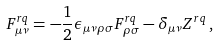<formula> <loc_0><loc_0><loc_500><loc_500>F _ { \mu \nu } ^ { r q } = - \frac { 1 } { 2 } \epsilon _ { \mu \nu \rho \sigma } F _ { \rho \sigma } ^ { r q } - \delta _ { \mu \nu } Z ^ { r q } \, ,</formula> 